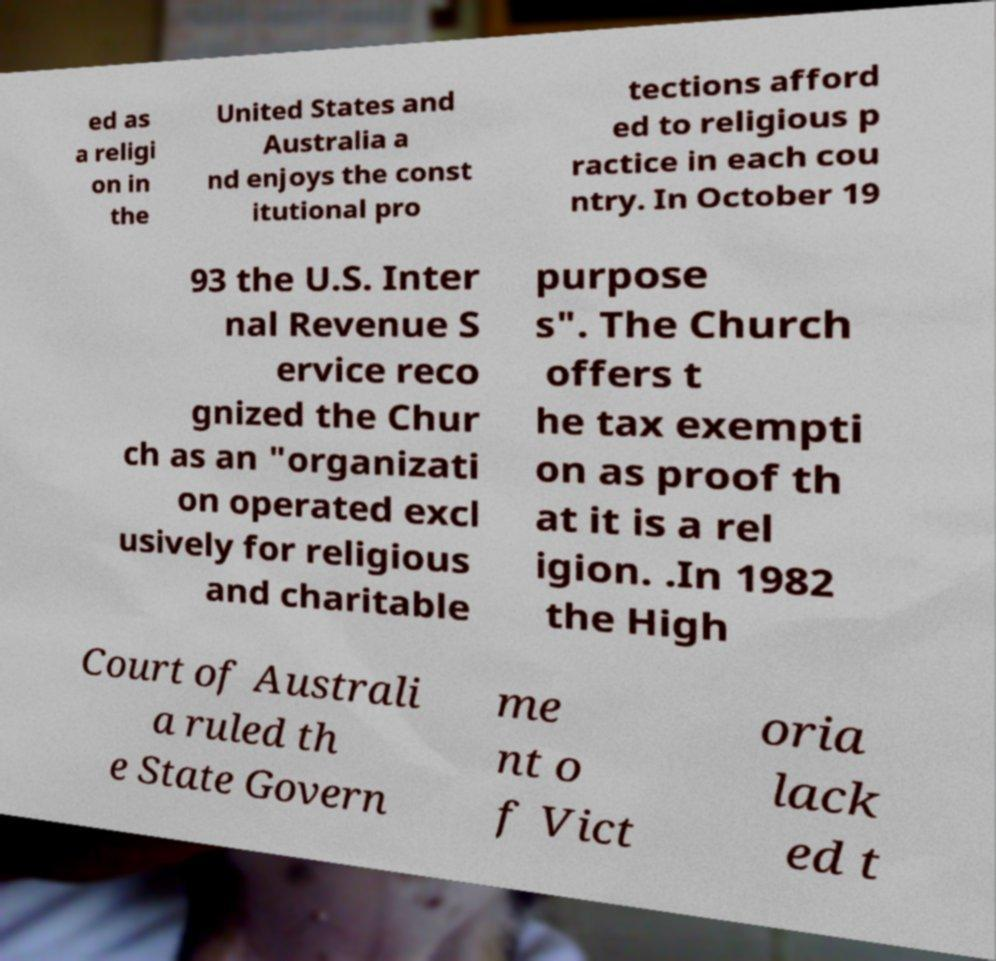Can you read and provide the text displayed in the image?This photo seems to have some interesting text. Can you extract and type it out for me? ed as a religi on in the United States and Australia a nd enjoys the const itutional pro tections afford ed to religious p ractice in each cou ntry. In October 19 93 the U.S. Inter nal Revenue S ervice reco gnized the Chur ch as an "organizati on operated excl usively for religious and charitable purpose s". The Church offers t he tax exempti on as proof th at it is a rel igion. .In 1982 the High Court of Australi a ruled th e State Govern me nt o f Vict oria lack ed t 